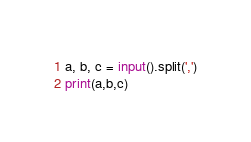Convert code to text. <code><loc_0><loc_0><loc_500><loc_500><_Python_>a, b, c = input().split(',')
print(a,b,c)</code> 